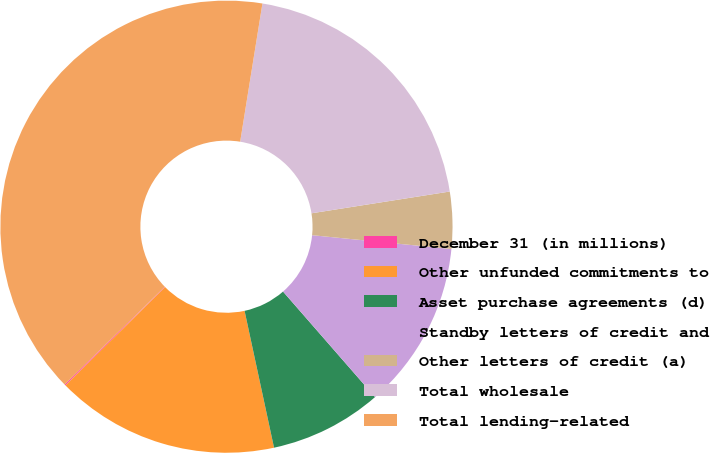Convert chart to OTSL. <chart><loc_0><loc_0><loc_500><loc_500><pie_chart><fcel>December 31 (in millions)<fcel>Other unfunded commitments to<fcel>Asset purchase agreements (d)<fcel>Standby letters of credit and<fcel>Other letters of credit (a)<fcel>Total wholesale<fcel>Total lending-related<nl><fcel>0.08%<fcel>15.99%<fcel>8.04%<fcel>12.01%<fcel>4.06%<fcel>19.97%<fcel>39.85%<nl></chart> 